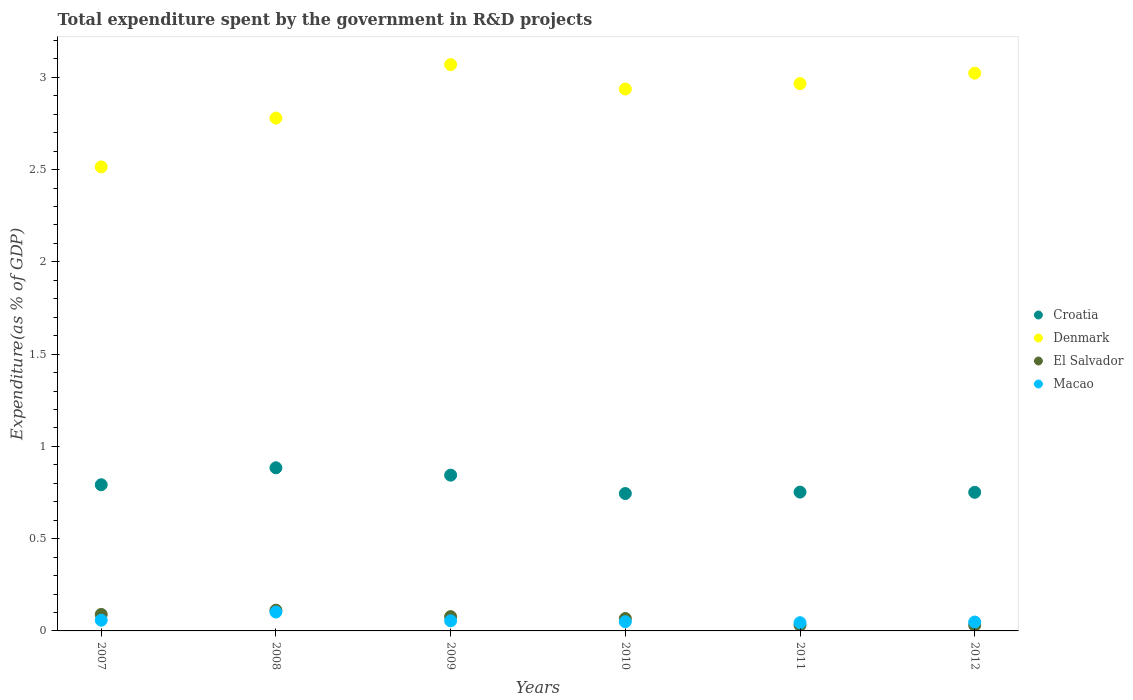What is the total expenditure spent by the government in R&D projects in El Salvador in 2008?
Make the answer very short. 0.11. Across all years, what is the maximum total expenditure spent by the government in R&D projects in Denmark?
Your answer should be compact. 3.07. Across all years, what is the minimum total expenditure spent by the government in R&D projects in Croatia?
Your answer should be very brief. 0.74. In which year was the total expenditure spent by the government in R&D projects in El Salvador minimum?
Provide a short and direct response. 2012. What is the total total expenditure spent by the government in R&D projects in Denmark in the graph?
Your response must be concise. 17.29. What is the difference between the total expenditure spent by the government in R&D projects in El Salvador in 2009 and that in 2012?
Provide a succinct answer. 0.05. What is the difference between the total expenditure spent by the government in R&D projects in Croatia in 2009 and the total expenditure spent by the government in R&D projects in Macao in 2012?
Give a very brief answer. 0.8. What is the average total expenditure spent by the government in R&D projects in Macao per year?
Ensure brevity in your answer.  0.06. In the year 2009, what is the difference between the total expenditure spent by the government in R&D projects in Denmark and total expenditure spent by the government in R&D projects in Croatia?
Offer a very short reply. 2.23. What is the ratio of the total expenditure spent by the government in R&D projects in Croatia in 2008 to that in 2011?
Make the answer very short. 1.18. Is the total expenditure spent by the government in R&D projects in El Salvador in 2008 less than that in 2011?
Your answer should be very brief. No. What is the difference between the highest and the second highest total expenditure spent by the government in R&D projects in Denmark?
Make the answer very short. 0.05. What is the difference between the highest and the lowest total expenditure spent by the government in R&D projects in Croatia?
Provide a short and direct response. 0.14. In how many years, is the total expenditure spent by the government in R&D projects in Denmark greater than the average total expenditure spent by the government in R&D projects in Denmark taken over all years?
Keep it short and to the point. 4. Is the sum of the total expenditure spent by the government in R&D projects in Macao in 2009 and 2010 greater than the maximum total expenditure spent by the government in R&D projects in Denmark across all years?
Ensure brevity in your answer.  No. Is it the case that in every year, the sum of the total expenditure spent by the government in R&D projects in Macao and total expenditure spent by the government in R&D projects in Croatia  is greater than the sum of total expenditure spent by the government in R&D projects in Denmark and total expenditure spent by the government in R&D projects in El Salvador?
Give a very brief answer. No. Is it the case that in every year, the sum of the total expenditure spent by the government in R&D projects in Macao and total expenditure spent by the government in R&D projects in Denmark  is greater than the total expenditure spent by the government in R&D projects in El Salvador?
Ensure brevity in your answer.  Yes. Is the total expenditure spent by the government in R&D projects in Macao strictly greater than the total expenditure spent by the government in R&D projects in Croatia over the years?
Ensure brevity in your answer.  No. Is the total expenditure spent by the government in R&D projects in Macao strictly less than the total expenditure spent by the government in R&D projects in Croatia over the years?
Provide a short and direct response. Yes. How many years are there in the graph?
Offer a very short reply. 6. Are the values on the major ticks of Y-axis written in scientific E-notation?
Give a very brief answer. No. Does the graph contain grids?
Provide a short and direct response. No. What is the title of the graph?
Provide a succinct answer. Total expenditure spent by the government in R&D projects. Does "New Zealand" appear as one of the legend labels in the graph?
Ensure brevity in your answer.  No. What is the label or title of the X-axis?
Your answer should be very brief. Years. What is the label or title of the Y-axis?
Give a very brief answer. Expenditure(as % of GDP). What is the Expenditure(as % of GDP) of Croatia in 2007?
Your response must be concise. 0.79. What is the Expenditure(as % of GDP) of Denmark in 2007?
Provide a short and direct response. 2.51. What is the Expenditure(as % of GDP) in El Salvador in 2007?
Ensure brevity in your answer.  0.09. What is the Expenditure(as % of GDP) in Macao in 2007?
Ensure brevity in your answer.  0.06. What is the Expenditure(as % of GDP) in Croatia in 2008?
Ensure brevity in your answer.  0.88. What is the Expenditure(as % of GDP) in Denmark in 2008?
Your answer should be compact. 2.78. What is the Expenditure(as % of GDP) of El Salvador in 2008?
Make the answer very short. 0.11. What is the Expenditure(as % of GDP) in Macao in 2008?
Offer a very short reply. 0.1. What is the Expenditure(as % of GDP) in Croatia in 2009?
Make the answer very short. 0.84. What is the Expenditure(as % of GDP) in Denmark in 2009?
Your response must be concise. 3.07. What is the Expenditure(as % of GDP) of El Salvador in 2009?
Offer a terse response. 0.08. What is the Expenditure(as % of GDP) in Macao in 2009?
Keep it short and to the point. 0.05. What is the Expenditure(as % of GDP) of Croatia in 2010?
Offer a very short reply. 0.74. What is the Expenditure(as % of GDP) in Denmark in 2010?
Provide a succinct answer. 2.94. What is the Expenditure(as % of GDP) of El Salvador in 2010?
Your response must be concise. 0.07. What is the Expenditure(as % of GDP) of Macao in 2010?
Make the answer very short. 0.05. What is the Expenditure(as % of GDP) in Croatia in 2011?
Offer a terse response. 0.75. What is the Expenditure(as % of GDP) in Denmark in 2011?
Your answer should be compact. 2.97. What is the Expenditure(as % of GDP) of El Salvador in 2011?
Provide a succinct answer. 0.03. What is the Expenditure(as % of GDP) in Macao in 2011?
Provide a short and direct response. 0.04. What is the Expenditure(as % of GDP) in Croatia in 2012?
Your response must be concise. 0.75. What is the Expenditure(as % of GDP) in Denmark in 2012?
Provide a succinct answer. 3.02. What is the Expenditure(as % of GDP) in El Salvador in 2012?
Offer a terse response. 0.03. What is the Expenditure(as % of GDP) of Macao in 2012?
Your response must be concise. 0.05. Across all years, what is the maximum Expenditure(as % of GDP) in Croatia?
Provide a short and direct response. 0.88. Across all years, what is the maximum Expenditure(as % of GDP) of Denmark?
Make the answer very short. 3.07. Across all years, what is the maximum Expenditure(as % of GDP) of El Salvador?
Keep it short and to the point. 0.11. Across all years, what is the maximum Expenditure(as % of GDP) of Macao?
Make the answer very short. 0.1. Across all years, what is the minimum Expenditure(as % of GDP) of Croatia?
Make the answer very short. 0.74. Across all years, what is the minimum Expenditure(as % of GDP) in Denmark?
Provide a succinct answer. 2.51. Across all years, what is the minimum Expenditure(as % of GDP) in El Salvador?
Keep it short and to the point. 0.03. Across all years, what is the minimum Expenditure(as % of GDP) in Macao?
Give a very brief answer. 0.04. What is the total Expenditure(as % of GDP) in Croatia in the graph?
Keep it short and to the point. 4.77. What is the total Expenditure(as % of GDP) in Denmark in the graph?
Provide a short and direct response. 17.29. What is the total Expenditure(as % of GDP) in El Salvador in the graph?
Keep it short and to the point. 0.41. What is the total Expenditure(as % of GDP) of Macao in the graph?
Offer a terse response. 0.36. What is the difference between the Expenditure(as % of GDP) in Croatia in 2007 and that in 2008?
Your response must be concise. -0.09. What is the difference between the Expenditure(as % of GDP) in Denmark in 2007 and that in 2008?
Give a very brief answer. -0.26. What is the difference between the Expenditure(as % of GDP) in El Salvador in 2007 and that in 2008?
Your response must be concise. -0.02. What is the difference between the Expenditure(as % of GDP) in Macao in 2007 and that in 2008?
Offer a very short reply. -0.04. What is the difference between the Expenditure(as % of GDP) in Croatia in 2007 and that in 2009?
Your answer should be compact. -0.05. What is the difference between the Expenditure(as % of GDP) of Denmark in 2007 and that in 2009?
Your answer should be very brief. -0.55. What is the difference between the Expenditure(as % of GDP) in El Salvador in 2007 and that in 2009?
Provide a short and direct response. 0.01. What is the difference between the Expenditure(as % of GDP) in Macao in 2007 and that in 2009?
Your answer should be very brief. 0. What is the difference between the Expenditure(as % of GDP) in Croatia in 2007 and that in 2010?
Ensure brevity in your answer.  0.05. What is the difference between the Expenditure(as % of GDP) in Denmark in 2007 and that in 2010?
Your response must be concise. -0.42. What is the difference between the Expenditure(as % of GDP) of El Salvador in 2007 and that in 2010?
Ensure brevity in your answer.  0.02. What is the difference between the Expenditure(as % of GDP) in Macao in 2007 and that in 2010?
Provide a succinct answer. 0.01. What is the difference between the Expenditure(as % of GDP) in Croatia in 2007 and that in 2011?
Provide a succinct answer. 0.04. What is the difference between the Expenditure(as % of GDP) in Denmark in 2007 and that in 2011?
Ensure brevity in your answer.  -0.45. What is the difference between the Expenditure(as % of GDP) in El Salvador in 2007 and that in 2011?
Provide a succinct answer. 0.06. What is the difference between the Expenditure(as % of GDP) in Macao in 2007 and that in 2011?
Keep it short and to the point. 0.01. What is the difference between the Expenditure(as % of GDP) of Croatia in 2007 and that in 2012?
Offer a terse response. 0.04. What is the difference between the Expenditure(as % of GDP) in Denmark in 2007 and that in 2012?
Offer a terse response. -0.51. What is the difference between the Expenditure(as % of GDP) in El Salvador in 2007 and that in 2012?
Give a very brief answer. 0.06. What is the difference between the Expenditure(as % of GDP) of Croatia in 2008 and that in 2009?
Offer a terse response. 0.04. What is the difference between the Expenditure(as % of GDP) in Denmark in 2008 and that in 2009?
Provide a short and direct response. -0.29. What is the difference between the Expenditure(as % of GDP) in El Salvador in 2008 and that in 2009?
Keep it short and to the point. 0.04. What is the difference between the Expenditure(as % of GDP) in Macao in 2008 and that in 2009?
Provide a short and direct response. 0.05. What is the difference between the Expenditure(as % of GDP) of Croatia in 2008 and that in 2010?
Provide a short and direct response. 0.14. What is the difference between the Expenditure(as % of GDP) of Denmark in 2008 and that in 2010?
Offer a very short reply. -0.16. What is the difference between the Expenditure(as % of GDP) in El Salvador in 2008 and that in 2010?
Your response must be concise. 0.05. What is the difference between the Expenditure(as % of GDP) in Macao in 2008 and that in 2010?
Make the answer very short. 0.05. What is the difference between the Expenditure(as % of GDP) of Croatia in 2008 and that in 2011?
Your answer should be compact. 0.13. What is the difference between the Expenditure(as % of GDP) in Denmark in 2008 and that in 2011?
Make the answer very short. -0.19. What is the difference between the Expenditure(as % of GDP) of El Salvador in 2008 and that in 2011?
Your response must be concise. 0.08. What is the difference between the Expenditure(as % of GDP) of Macao in 2008 and that in 2011?
Offer a very short reply. 0.06. What is the difference between the Expenditure(as % of GDP) in Croatia in 2008 and that in 2012?
Ensure brevity in your answer.  0.13. What is the difference between the Expenditure(as % of GDP) of Denmark in 2008 and that in 2012?
Give a very brief answer. -0.24. What is the difference between the Expenditure(as % of GDP) in El Salvador in 2008 and that in 2012?
Keep it short and to the point. 0.08. What is the difference between the Expenditure(as % of GDP) of Macao in 2008 and that in 2012?
Provide a short and direct response. 0.05. What is the difference between the Expenditure(as % of GDP) of Croatia in 2009 and that in 2010?
Provide a short and direct response. 0.1. What is the difference between the Expenditure(as % of GDP) in Denmark in 2009 and that in 2010?
Offer a terse response. 0.13. What is the difference between the Expenditure(as % of GDP) of El Salvador in 2009 and that in 2010?
Offer a very short reply. 0.01. What is the difference between the Expenditure(as % of GDP) of Macao in 2009 and that in 2010?
Provide a short and direct response. 0. What is the difference between the Expenditure(as % of GDP) in Croatia in 2009 and that in 2011?
Your answer should be very brief. 0.09. What is the difference between the Expenditure(as % of GDP) of Denmark in 2009 and that in 2011?
Your answer should be very brief. 0.1. What is the difference between the Expenditure(as % of GDP) of El Salvador in 2009 and that in 2011?
Provide a short and direct response. 0.05. What is the difference between the Expenditure(as % of GDP) of Macao in 2009 and that in 2011?
Keep it short and to the point. 0.01. What is the difference between the Expenditure(as % of GDP) in Croatia in 2009 and that in 2012?
Your answer should be very brief. 0.09. What is the difference between the Expenditure(as % of GDP) in Denmark in 2009 and that in 2012?
Give a very brief answer. 0.05. What is the difference between the Expenditure(as % of GDP) in El Salvador in 2009 and that in 2012?
Ensure brevity in your answer.  0.05. What is the difference between the Expenditure(as % of GDP) of Macao in 2009 and that in 2012?
Your response must be concise. 0.01. What is the difference between the Expenditure(as % of GDP) in Croatia in 2010 and that in 2011?
Make the answer very short. -0.01. What is the difference between the Expenditure(as % of GDP) of Denmark in 2010 and that in 2011?
Offer a very short reply. -0.03. What is the difference between the Expenditure(as % of GDP) of El Salvador in 2010 and that in 2011?
Your response must be concise. 0.04. What is the difference between the Expenditure(as % of GDP) of Macao in 2010 and that in 2011?
Ensure brevity in your answer.  0.01. What is the difference between the Expenditure(as % of GDP) of Croatia in 2010 and that in 2012?
Your answer should be compact. -0.01. What is the difference between the Expenditure(as % of GDP) in Denmark in 2010 and that in 2012?
Offer a very short reply. -0.09. What is the difference between the Expenditure(as % of GDP) of El Salvador in 2010 and that in 2012?
Your answer should be compact. 0.04. What is the difference between the Expenditure(as % of GDP) of Macao in 2010 and that in 2012?
Your answer should be compact. 0. What is the difference between the Expenditure(as % of GDP) in Croatia in 2011 and that in 2012?
Make the answer very short. 0. What is the difference between the Expenditure(as % of GDP) of Denmark in 2011 and that in 2012?
Your answer should be very brief. -0.06. What is the difference between the Expenditure(as % of GDP) of El Salvador in 2011 and that in 2012?
Provide a short and direct response. 0. What is the difference between the Expenditure(as % of GDP) in Macao in 2011 and that in 2012?
Ensure brevity in your answer.  -0. What is the difference between the Expenditure(as % of GDP) in Croatia in 2007 and the Expenditure(as % of GDP) in Denmark in 2008?
Offer a very short reply. -1.99. What is the difference between the Expenditure(as % of GDP) of Croatia in 2007 and the Expenditure(as % of GDP) of El Salvador in 2008?
Make the answer very short. 0.68. What is the difference between the Expenditure(as % of GDP) of Croatia in 2007 and the Expenditure(as % of GDP) of Macao in 2008?
Provide a short and direct response. 0.69. What is the difference between the Expenditure(as % of GDP) in Denmark in 2007 and the Expenditure(as % of GDP) in El Salvador in 2008?
Provide a succinct answer. 2.4. What is the difference between the Expenditure(as % of GDP) of Denmark in 2007 and the Expenditure(as % of GDP) of Macao in 2008?
Your response must be concise. 2.41. What is the difference between the Expenditure(as % of GDP) in El Salvador in 2007 and the Expenditure(as % of GDP) in Macao in 2008?
Offer a terse response. -0.01. What is the difference between the Expenditure(as % of GDP) of Croatia in 2007 and the Expenditure(as % of GDP) of Denmark in 2009?
Give a very brief answer. -2.28. What is the difference between the Expenditure(as % of GDP) of Croatia in 2007 and the Expenditure(as % of GDP) of El Salvador in 2009?
Provide a short and direct response. 0.71. What is the difference between the Expenditure(as % of GDP) in Croatia in 2007 and the Expenditure(as % of GDP) in Macao in 2009?
Ensure brevity in your answer.  0.74. What is the difference between the Expenditure(as % of GDP) in Denmark in 2007 and the Expenditure(as % of GDP) in El Salvador in 2009?
Your response must be concise. 2.44. What is the difference between the Expenditure(as % of GDP) in Denmark in 2007 and the Expenditure(as % of GDP) in Macao in 2009?
Provide a short and direct response. 2.46. What is the difference between the Expenditure(as % of GDP) of El Salvador in 2007 and the Expenditure(as % of GDP) of Macao in 2009?
Make the answer very short. 0.03. What is the difference between the Expenditure(as % of GDP) of Croatia in 2007 and the Expenditure(as % of GDP) of Denmark in 2010?
Make the answer very short. -2.14. What is the difference between the Expenditure(as % of GDP) of Croatia in 2007 and the Expenditure(as % of GDP) of El Salvador in 2010?
Give a very brief answer. 0.72. What is the difference between the Expenditure(as % of GDP) of Croatia in 2007 and the Expenditure(as % of GDP) of Macao in 2010?
Provide a short and direct response. 0.74. What is the difference between the Expenditure(as % of GDP) of Denmark in 2007 and the Expenditure(as % of GDP) of El Salvador in 2010?
Your response must be concise. 2.45. What is the difference between the Expenditure(as % of GDP) of Denmark in 2007 and the Expenditure(as % of GDP) of Macao in 2010?
Provide a short and direct response. 2.46. What is the difference between the Expenditure(as % of GDP) in El Salvador in 2007 and the Expenditure(as % of GDP) in Macao in 2010?
Your response must be concise. 0.04. What is the difference between the Expenditure(as % of GDP) of Croatia in 2007 and the Expenditure(as % of GDP) of Denmark in 2011?
Ensure brevity in your answer.  -2.17. What is the difference between the Expenditure(as % of GDP) in Croatia in 2007 and the Expenditure(as % of GDP) in El Salvador in 2011?
Make the answer very short. 0.76. What is the difference between the Expenditure(as % of GDP) of Croatia in 2007 and the Expenditure(as % of GDP) of Macao in 2011?
Your answer should be very brief. 0.75. What is the difference between the Expenditure(as % of GDP) of Denmark in 2007 and the Expenditure(as % of GDP) of El Salvador in 2011?
Give a very brief answer. 2.48. What is the difference between the Expenditure(as % of GDP) of Denmark in 2007 and the Expenditure(as % of GDP) of Macao in 2011?
Give a very brief answer. 2.47. What is the difference between the Expenditure(as % of GDP) of El Salvador in 2007 and the Expenditure(as % of GDP) of Macao in 2011?
Make the answer very short. 0.04. What is the difference between the Expenditure(as % of GDP) of Croatia in 2007 and the Expenditure(as % of GDP) of Denmark in 2012?
Make the answer very short. -2.23. What is the difference between the Expenditure(as % of GDP) in Croatia in 2007 and the Expenditure(as % of GDP) in El Salvador in 2012?
Offer a very short reply. 0.76. What is the difference between the Expenditure(as % of GDP) of Croatia in 2007 and the Expenditure(as % of GDP) of Macao in 2012?
Your answer should be compact. 0.74. What is the difference between the Expenditure(as % of GDP) of Denmark in 2007 and the Expenditure(as % of GDP) of El Salvador in 2012?
Provide a short and direct response. 2.48. What is the difference between the Expenditure(as % of GDP) in Denmark in 2007 and the Expenditure(as % of GDP) in Macao in 2012?
Provide a short and direct response. 2.47. What is the difference between the Expenditure(as % of GDP) of El Salvador in 2007 and the Expenditure(as % of GDP) of Macao in 2012?
Your answer should be compact. 0.04. What is the difference between the Expenditure(as % of GDP) in Croatia in 2008 and the Expenditure(as % of GDP) in Denmark in 2009?
Provide a succinct answer. -2.19. What is the difference between the Expenditure(as % of GDP) of Croatia in 2008 and the Expenditure(as % of GDP) of El Salvador in 2009?
Your response must be concise. 0.81. What is the difference between the Expenditure(as % of GDP) in Croatia in 2008 and the Expenditure(as % of GDP) in Macao in 2009?
Your answer should be very brief. 0.83. What is the difference between the Expenditure(as % of GDP) in Denmark in 2008 and the Expenditure(as % of GDP) in El Salvador in 2009?
Keep it short and to the point. 2.7. What is the difference between the Expenditure(as % of GDP) in Denmark in 2008 and the Expenditure(as % of GDP) in Macao in 2009?
Your response must be concise. 2.72. What is the difference between the Expenditure(as % of GDP) in El Salvador in 2008 and the Expenditure(as % of GDP) in Macao in 2009?
Keep it short and to the point. 0.06. What is the difference between the Expenditure(as % of GDP) in Croatia in 2008 and the Expenditure(as % of GDP) in Denmark in 2010?
Your response must be concise. -2.05. What is the difference between the Expenditure(as % of GDP) of Croatia in 2008 and the Expenditure(as % of GDP) of El Salvador in 2010?
Give a very brief answer. 0.82. What is the difference between the Expenditure(as % of GDP) of Croatia in 2008 and the Expenditure(as % of GDP) of Macao in 2010?
Make the answer very short. 0.83. What is the difference between the Expenditure(as % of GDP) of Denmark in 2008 and the Expenditure(as % of GDP) of El Salvador in 2010?
Give a very brief answer. 2.71. What is the difference between the Expenditure(as % of GDP) in Denmark in 2008 and the Expenditure(as % of GDP) in Macao in 2010?
Your answer should be compact. 2.73. What is the difference between the Expenditure(as % of GDP) in El Salvador in 2008 and the Expenditure(as % of GDP) in Macao in 2010?
Make the answer very short. 0.06. What is the difference between the Expenditure(as % of GDP) in Croatia in 2008 and the Expenditure(as % of GDP) in Denmark in 2011?
Offer a very short reply. -2.08. What is the difference between the Expenditure(as % of GDP) of Croatia in 2008 and the Expenditure(as % of GDP) of El Salvador in 2011?
Give a very brief answer. 0.85. What is the difference between the Expenditure(as % of GDP) in Croatia in 2008 and the Expenditure(as % of GDP) in Macao in 2011?
Keep it short and to the point. 0.84. What is the difference between the Expenditure(as % of GDP) of Denmark in 2008 and the Expenditure(as % of GDP) of El Salvador in 2011?
Make the answer very short. 2.75. What is the difference between the Expenditure(as % of GDP) of Denmark in 2008 and the Expenditure(as % of GDP) of Macao in 2011?
Provide a succinct answer. 2.73. What is the difference between the Expenditure(as % of GDP) in El Salvador in 2008 and the Expenditure(as % of GDP) in Macao in 2011?
Give a very brief answer. 0.07. What is the difference between the Expenditure(as % of GDP) of Croatia in 2008 and the Expenditure(as % of GDP) of Denmark in 2012?
Your answer should be compact. -2.14. What is the difference between the Expenditure(as % of GDP) of Croatia in 2008 and the Expenditure(as % of GDP) of El Salvador in 2012?
Make the answer very short. 0.85. What is the difference between the Expenditure(as % of GDP) of Croatia in 2008 and the Expenditure(as % of GDP) of Macao in 2012?
Provide a short and direct response. 0.84. What is the difference between the Expenditure(as % of GDP) of Denmark in 2008 and the Expenditure(as % of GDP) of El Salvador in 2012?
Offer a very short reply. 2.75. What is the difference between the Expenditure(as % of GDP) in Denmark in 2008 and the Expenditure(as % of GDP) in Macao in 2012?
Provide a short and direct response. 2.73. What is the difference between the Expenditure(as % of GDP) of El Salvador in 2008 and the Expenditure(as % of GDP) of Macao in 2012?
Offer a terse response. 0.06. What is the difference between the Expenditure(as % of GDP) of Croatia in 2009 and the Expenditure(as % of GDP) of Denmark in 2010?
Make the answer very short. -2.09. What is the difference between the Expenditure(as % of GDP) in Croatia in 2009 and the Expenditure(as % of GDP) in El Salvador in 2010?
Your answer should be compact. 0.78. What is the difference between the Expenditure(as % of GDP) of Croatia in 2009 and the Expenditure(as % of GDP) of Macao in 2010?
Your answer should be very brief. 0.79. What is the difference between the Expenditure(as % of GDP) in Denmark in 2009 and the Expenditure(as % of GDP) in El Salvador in 2010?
Ensure brevity in your answer.  3. What is the difference between the Expenditure(as % of GDP) of Denmark in 2009 and the Expenditure(as % of GDP) of Macao in 2010?
Offer a terse response. 3.02. What is the difference between the Expenditure(as % of GDP) in El Salvador in 2009 and the Expenditure(as % of GDP) in Macao in 2010?
Offer a very short reply. 0.03. What is the difference between the Expenditure(as % of GDP) of Croatia in 2009 and the Expenditure(as % of GDP) of Denmark in 2011?
Ensure brevity in your answer.  -2.12. What is the difference between the Expenditure(as % of GDP) in Croatia in 2009 and the Expenditure(as % of GDP) in El Salvador in 2011?
Offer a terse response. 0.81. What is the difference between the Expenditure(as % of GDP) in Croatia in 2009 and the Expenditure(as % of GDP) in Macao in 2011?
Provide a short and direct response. 0.8. What is the difference between the Expenditure(as % of GDP) in Denmark in 2009 and the Expenditure(as % of GDP) in El Salvador in 2011?
Ensure brevity in your answer.  3.04. What is the difference between the Expenditure(as % of GDP) of Denmark in 2009 and the Expenditure(as % of GDP) of Macao in 2011?
Offer a terse response. 3.02. What is the difference between the Expenditure(as % of GDP) in El Salvador in 2009 and the Expenditure(as % of GDP) in Macao in 2011?
Offer a terse response. 0.03. What is the difference between the Expenditure(as % of GDP) of Croatia in 2009 and the Expenditure(as % of GDP) of Denmark in 2012?
Give a very brief answer. -2.18. What is the difference between the Expenditure(as % of GDP) in Croatia in 2009 and the Expenditure(as % of GDP) in El Salvador in 2012?
Your answer should be very brief. 0.81. What is the difference between the Expenditure(as % of GDP) of Croatia in 2009 and the Expenditure(as % of GDP) of Macao in 2012?
Offer a terse response. 0.8. What is the difference between the Expenditure(as % of GDP) in Denmark in 2009 and the Expenditure(as % of GDP) in El Salvador in 2012?
Ensure brevity in your answer.  3.04. What is the difference between the Expenditure(as % of GDP) in Denmark in 2009 and the Expenditure(as % of GDP) in Macao in 2012?
Provide a succinct answer. 3.02. What is the difference between the Expenditure(as % of GDP) in El Salvador in 2009 and the Expenditure(as % of GDP) in Macao in 2012?
Provide a succinct answer. 0.03. What is the difference between the Expenditure(as % of GDP) in Croatia in 2010 and the Expenditure(as % of GDP) in Denmark in 2011?
Ensure brevity in your answer.  -2.22. What is the difference between the Expenditure(as % of GDP) of Croatia in 2010 and the Expenditure(as % of GDP) of El Salvador in 2011?
Ensure brevity in your answer.  0.71. What is the difference between the Expenditure(as % of GDP) in Croatia in 2010 and the Expenditure(as % of GDP) in Macao in 2011?
Offer a very short reply. 0.7. What is the difference between the Expenditure(as % of GDP) in Denmark in 2010 and the Expenditure(as % of GDP) in El Salvador in 2011?
Ensure brevity in your answer.  2.91. What is the difference between the Expenditure(as % of GDP) of Denmark in 2010 and the Expenditure(as % of GDP) of Macao in 2011?
Offer a terse response. 2.89. What is the difference between the Expenditure(as % of GDP) of El Salvador in 2010 and the Expenditure(as % of GDP) of Macao in 2011?
Keep it short and to the point. 0.02. What is the difference between the Expenditure(as % of GDP) of Croatia in 2010 and the Expenditure(as % of GDP) of Denmark in 2012?
Ensure brevity in your answer.  -2.28. What is the difference between the Expenditure(as % of GDP) of Croatia in 2010 and the Expenditure(as % of GDP) of El Salvador in 2012?
Keep it short and to the point. 0.71. What is the difference between the Expenditure(as % of GDP) of Croatia in 2010 and the Expenditure(as % of GDP) of Macao in 2012?
Your answer should be very brief. 0.7. What is the difference between the Expenditure(as % of GDP) in Denmark in 2010 and the Expenditure(as % of GDP) in El Salvador in 2012?
Offer a very short reply. 2.91. What is the difference between the Expenditure(as % of GDP) of Denmark in 2010 and the Expenditure(as % of GDP) of Macao in 2012?
Provide a short and direct response. 2.89. What is the difference between the Expenditure(as % of GDP) in El Salvador in 2010 and the Expenditure(as % of GDP) in Macao in 2012?
Offer a terse response. 0.02. What is the difference between the Expenditure(as % of GDP) of Croatia in 2011 and the Expenditure(as % of GDP) of Denmark in 2012?
Ensure brevity in your answer.  -2.27. What is the difference between the Expenditure(as % of GDP) of Croatia in 2011 and the Expenditure(as % of GDP) of El Salvador in 2012?
Ensure brevity in your answer.  0.72. What is the difference between the Expenditure(as % of GDP) in Croatia in 2011 and the Expenditure(as % of GDP) in Macao in 2012?
Make the answer very short. 0.7. What is the difference between the Expenditure(as % of GDP) of Denmark in 2011 and the Expenditure(as % of GDP) of El Salvador in 2012?
Provide a succinct answer. 2.94. What is the difference between the Expenditure(as % of GDP) in Denmark in 2011 and the Expenditure(as % of GDP) in Macao in 2012?
Your answer should be very brief. 2.92. What is the difference between the Expenditure(as % of GDP) in El Salvador in 2011 and the Expenditure(as % of GDP) in Macao in 2012?
Your answer should be very brief. -0.02. What is the average Expenditure(as % of GDP) of Croatia per year?
Offer a very short reply. 0.79. What is the average Expenditure(as % of GDP) in Denmark per year?
Your response must be concise. 2.88. What is the average Expenditure(as % of GDP) in El Salvador per year?
Ensure brevity in your answer.  0.07. What is the average Expenditure(as % of GDP) of Macao per year?
Provide a succinct answer. 0.06. In the year 2007, what is the difference between the Expenditure(as % of GDP) in Croatia and Expenditure(as % of GDP) in Denmark?
Provide a short and direct response. -1.72. In the year 2007, what is the difference between the Expenditure(as % of GDP) of Croatia and Expenditure(as % of GDP) of El Salvador?
Your answer should be very brief. 0.7. In the year 2007, what is the difference between the Expenditure(as % of GDP) in Croatia and Expenditure(as % of GDP) in Macao?
Your answer should be very brief. 0.73. In the year 2007, what is the difference between the Expenditure(as % of GDP) of Denmark and Expenditure(as % of GDP) of El Salvador?
Provide a succinct answer. 2.43. In the year 2007, what is the difference between the Expenditure(as % of GDP) in Denmark and Expenditure(as % of GDP) in Macao?
Your answer should be compact. 2.46. In the year 2007, what is the difference between the Expenditure(as % of GDP) of El Salvador and Expenditure(as % of GDP) of Macao?
Provide a succinct answer. 0.03. In the year 2008, what is the difference between the Expenditure(as % of GDP) in Croatia and Expenditure(as % of GDP) in Denmark?
Your response must be concise. -1.9. In the year 2008, what is the difference between the Expenditure(as % of GDP) in Croatia and Expenditure(as % of GDP) in El Salvador?
Your answer should be compact. 0.77. In the year 2008, what is the difference between the Expenditure(as % of GDP) of Croatia and Expenditure(as % of GDP) of Macao?
Give a very brief answer. 0.78. In the year 2008, what is the difference between the Expenditure(as % of GDP) in Denmark and Expenditure(as % of GDP) in El Salvador?
Your response must be concise. 2.67. In the year 2008, what is the difference between the Expenditure(as % of GDP) of Denmark and Expenditure(as % of GDP) of Macao?
Your answer should be compact. 2.68. In the year 2008, what is the difference between the Expenditure(as % of GDP) of El Salvador and Expenditure(as % of GDP) of Macao?
Your answer should be compact. 0.01. In the year 2009, what is the difference between the Expenditure(as % of GDP) of Croatia and Expenditure(as % of GDP) of Denmark?
Give a very brief answer. -2.23. In the year 2009, what is the difference between the Expenditure(as % of GDP) of Croatia and Expenditure(as % of GDP) of El Salvador?
Offer a very short reply. 0.77. In the year 2009, what is the difference between the Expenditure(as % of GDP) in Croatia and Expenditure(as % of GDP) in Macao?
Your response must be concise. 0.79. In the year 2009, what is the difference between the Expenditure(as % of GDP) of Denmark and Expenditure(as % of GDP) of El Salvador?
Your answer should be compact. 2.99. In the year 2009, what is the difference between the Expenditure(as % of GDP) in Denmark and Expenditure(as % of GDP) in Macao?
Keep it short and to the point. 3.01. In the year 2009, what is the difference between the Expenditure(as % of GDP) of El Salvador and Expenditure(as % of GDP) of Macao?
Offer a very short reply. 0.02. In the year 2010, what is the difference between the Expenditure(as % of GDP) of Croatia and Expenditure(as % of GDP) of Denmark?
Make the answer very short. -2.19. In the year 2010, what is the difference between the Expenditure(as % of GDP) of Croatia and Expenditure(as % of GDP) of El Salvador?
Offer a very short reply. 0.68. In the year 2010, what is the difference between the Expenditure(as % of GDP) in Croatia and Expenditure(as % of GDP) in Macao?
Provide a succinct answer. 0.69. In the year 2010, what is the difference between the Expenditure(as % of GDP) in Denmark and Expenditure(as % of GDP) in El Salvador?
Give a very brief answer. 2.87. In the year 2010, what is the difference between the Expenditure(as % of GDP) of Denmark and Expenditure(as % of GDP) of Macao?
Ensure brevity in your answer.  2.89. In the year 2010, what is the difference between the Expenditure(as % of GDP) in El Salvador and Expenditure(as % of GDP) in Macao?
Give a very brief answer. 0.02. In the year 2011, what is the difference between the Expenditure(as % of GDP) of Croatia and Expenditure(as % of GDP) of Denmark?
Provide a short and direct response. -2.21. In the year 2011, what is the difference between the Expenditure(as % of GDP) in Croatia and Expenditure(as % of GDP) in El Salvador?
Your answer should be very brief. 0.72. In the year 2011, what is the difference between the Expenditure(as % of GDP) of Croatia and Expenditure(as % of GDP) of Macao?
Your response must be concise. 0.71. In the year 2011, what is the difference between the Expenditure(as % of GDP) in Denmark and Expenditure(as % of GDP) in El Salvador?
Keep it short and to the point. 2.94. In the year 2011, what is the difference between the Expenditure(as % of GDP) of Denmark and Expenditure(as % of GDP) of Macao?
Provide a succinct answer. 2.92. In the year 2011, what is the difference between the Expenditure(as % of GDP) in El Salvador and Expenditure(as % of GDP) in Macao?
Ensure brevity in your answer.  -0.01. In the year 2012, what is the difference between the Expenditure(as % of GDP) of Croatia and Expenditure(as % of GDP) of Denmark?
Provide a short and direct response. -2.27. In the year 2012, what is the difference between the Expenditure(as % of GDP) of Croatia and Expenditure(as % of GDP) of El Salvador?
Provide a succinct answer. 0.72. In the year 2012, what is the difference between the Expenditure(as % of GDP) in Croatia and Expenditure(as % of GDP) in Macao?
Provide a succinct answer. 0.7. In the year 2012, what is the difference between the Expenditure(as % of GDP) in Denmark and Expenditure(as % of GDP) in El Salvador?
Give a very brief answer. 2.99. In the year 2012, what is the difference between the Expenditure(as % of GDP) of Denmark and Expenditure(as % of GDP) of Macao?
Offer a terse response. 2.97. In the year 2012, what is the difference between the Expenditure(as % of GDP) of El Salvador and Expenditure(as % of GDP) of Macao?
Give a very brief answer. -0.02. What is the ratio of the Expenditure(as % of GDP) of Croatia in 2007 to that in 2008?
Make the answer very short. 0.9. What is the ratio of the Expenditure(as % of GDP) in Denmark in 2007 to that in 2008?
Give a very brief answer. 0.9. What is the ratio of the Expenditure(as % of GDP) of El Salvador in 2007 to that in 2008?
Your answer should be compact. 0.79. What is the ratio of the Expenditure(as % of GDP) of Macao in 2007 to that in 2008?
Provide a short and direct response. 0.57. What is the ratio of the Expenditure(as % of GDP) of Croatia in 2007 to that in 2009?
Offer a very short reply. 0.94. What is the ratio of the Expenditure(as % of GDP) of Denmark in 2007 to that in 2009?
Ensure brevity in your answer.  0.82. What is the ratio of the Expenditure(as % of GDP) of El Salvador in 2007 to that in 2009?
Offer a very short reply. 1.15. What is the ratio of the Expenditure(as % of GDP) of Macao in 2007 to that in 2009?
Offer a terse response. 1.06. What is the ratio of the Expenditure(as % of GDP) of Croatia in 2007 to that in 2010?
Offer a terse response. 1.06. What is the ratio of the Expenditure(as % of GDP) in Denmark in 2007 to that in 2010?
Make the answer very short. 0.86. What is the ratio of the Expenditure(as % of GDP) in El Salvador in 2007 to that in 2010?
Make the answer very short. 1.33. What is the ratio of the Expenditure(as % of GDP) of Macao in 2007 to that in 2010?
Your answer should be compact. 1.16. What is the ratio of the Expenditure(as % of GDP) of Croatia in 2007 to that in 2011?
Give a very brief answer. 1.05. What is the ratio of the Expenditure(as % of GDP) in Denmark in 2007 to that in 2011?
Your answer should be very brief. 0.85. What is the ratio of the Expenditure(as % of GDP) of El Salvador in 2007 to that in 2011?
Provide a succinct answer. 2.87. What is the ratio of the Expenditure(as % of GDP) in Macao in 2007 to that in 2011?
Your answer should be very brief. 1.3. What is the ratio of the Expenditure(as % of GDP) of Croatia in 2007 to that in 2012?
Provide a short and direct response. 1.05. What is the ratio of the Expenditure(as % of GDP) in Denmark in 2007 to that in 2012?
Give a very brief answer. 0.83. What is the ratio of the Expenditure(as % of GDP) of El Salvador in 2007 to that in 2012?
Provide a succinct answer. 2.93. What is the ratio of the Expenditure(as % of GDP) of Macao in 2007 to that in 2012?
Offer a terse response. 1.21. What is the ratio of the Expenditure(as % of GDP) in Croatia in 2008 to that in 2009?
Provide a succinct answer. 1.05. What is the ratio of the Expenditure(as % of GDP) of Denmark in 2008 to that in 2009?
Give a very brief answer. 0.91. What is the ratio of the Expenditure(as % of GDP) of El Salvador in 2008 to that in 2009?
Your response must be concise. 1.45. What is the ratio of the Expenditure(as % of GDP) of Macao in 2008 to that in 2009?
Provide a short and direct response. 1.87. What is the ratio of the Expenditure(as % of GDP) of Croatia in 2008 to that in 2010?
Give a very brief answer. 1.19. What is the ratio of the Expenditure(as % of GDP) in Denmark in 2008 to that in 2010?
Ensure brevity in your answer.  0.95. What is the ratio of the Expenditure(as % of GDP) in El Salvador in 2008 to that in 2010?
Provide a short and direct response. 1.67. What is the ratio of the Expenditure(as % of GDP) in Macao in 2008 to that in 2010?
Make the answer very short. 2.05. What is the ratio of the Expenditure(as % of GDP) in Croatia in 2008 to that in 2011?
Your answer should be very brief. 1.18. What is the ratio of the Expenditure(as % of GDP) in Denmark in 2008 to that in 2011?
Provide a succinct answer. 0.94. What is the ratio of the Expenditure(as % of GDP) in El Salvador in 2008 to that in 2011?
Keep it short and to the point. 3.61. What is the ratio of the Expenditure(as % of GDP) in Macao in 2008 to that in 2011?
Make the answer very short. 2.3. What is the ratio of the Expenditure(as % of GDP) of Croatia in 2008 to that in 2012?
Your answer should be compact. 1.18. What is the ratio of the Expenditure(as % of GDP) of Denmark in 2008 to that in 2012?
Offer a very short reply. 0.92. What is the ratio of the Expenditure(as % of GDP) of El Salvador in 2008 to that in 2012?
Your answer should be very brief. 3.69. What is the ratio of the Expenditure(as % of GDP) in Macao in 2008 to that in 2012?
Your answer should be compact. 2.13. What is the ratio of the Expenditure(as % of GDP) in Croatia in 2009 to that in 2010?
Provide a succinct answer. 1.13. What is the ratio of the Expenditure(as % of GDP) of Denmark in 2009 to that in 2010?
Make the answer very short. 1.04. What is the ratio of the Expenditure(as % of GDP) of El Salvador in 2009 to that in 2010?
Provide a short and direct response. 1.15. What is the ratio of the Expenditure(as % of GDP) of Macao in 2009 to that in 2010?
Your answer should be compact. 1.1. What is the ratio of the Expenditure(as % of GDP) of Croatia in 2009 to that in 2011?
Provide a short and direct response. 1.12. What is the ratio of the Expenditure(as % of GDP) in Denmark in 2009 to that in 2011?
Provide a short and direct response. 1.03. What is the ratio of the Expenditure(as % of GDP) of El Salvador in 2009 to that in 2011?
Ensure brevity in your answer.  2.49. What is the ratio of the Expenditure(as % of GDP) of Macao in 2009 to that in 2011?
Offer a terse response. 1.23. What is the ratio of the Expenditure(as % of GDP) of Croatia in 2009 to that in 2012?
Offer a terse response. 1.12. What is the ratio of the Expenditure(as % of GDP) of Denmark in 2009 to that in 2012?
Keep it short and to the point. 1.02. What is the ratio of the Expenditure(as % of GDP) of El Salvador in 2009 to that in 2012?
Offer a very short reply. 2.54. What is the ratio of the Expenditure(as % of GDP) in Macao in 2009 to that in 2012?
Make the answer very short. 1.14. What is the ratio of the Expenditure(as % of GDP) of Croatia in 2010 to that in 2011?
Your answer should be very brief. 0.99. What is the ratio of the Expenditure(as % of GDP) of El Salvador in 2010 to that in 2011?
Ensure brevity in your answer.  2.16. What is the ratio of the Expenditure(as % of GDP) in Macao in 2010 to that in 2011?
Provide a succinct answer. 1.12. What is the ratio of the Expenditure(as % of GDP) of Croatia in 2010 to that in 2012?
Your answer should be very brief. 0.99. What is the ratio of the Expenditure(as % of GDP) in Denmark in 2010 to that in 2012?
Provide a short and direct response. 0.97. What is the ratio of the Expenditure(as % of GDP) in El Salvador in 2010 to that in 2012?
Your answer should be compact. 2.2. What is the ratio of the Expenditure(as % of GDP) in Macao in 2010 to that in 2012?
Give a very brief answer. 1.04. What is the ratio of the Expenditure(as % of GDP) of Denmark in 2011 to that in 2012?
Offer a terse response. 0.98. What is the ratio of the Expenditure(as % of GDP) in El Salvador in 2011 to that in 2012?
Offer a very short reply. 1.02. What is the ratio of the Expenditure(as % of GDP) in Macao in 2011 to that in 2012?
Keep it short and to the point. 0.93. What is the difference between the highest and the second highest Expenditure(as % of GDP) of Croatia?
Provide a succinct answer. 0.04. What is the difference between the highest and the second highest Expenditure(as % of GDP) in Denmark?
Your answer should be very brief. 0.05. What is the difference between the highest and the second highest Expenditure(as % of GDP) of El Salvador?
Make the answer very short. 0.02. What is the difference between the highest and the second highest Expenditure(as % of GDP) of Macao?
Keep it short and to the point. 0.04. What is the difference between the highest and the lowest Expenditure(as % of GDP) of Croatia?
Provide a short and direct response. 0.14. What is the difference between the highest and the lowest Expenditure(as % of GDP) of Denmark?
Keep it short and to the point. 0.55. What is the difference between the highest and the lowest Expenditure(as % of GDP) of El Salvador?
Your answer should be very brief. 0.08. What is the difference between the highest and the lowest Expenditure(as % of GDP) of Macao?
Your answer should be compact. 0.06. 